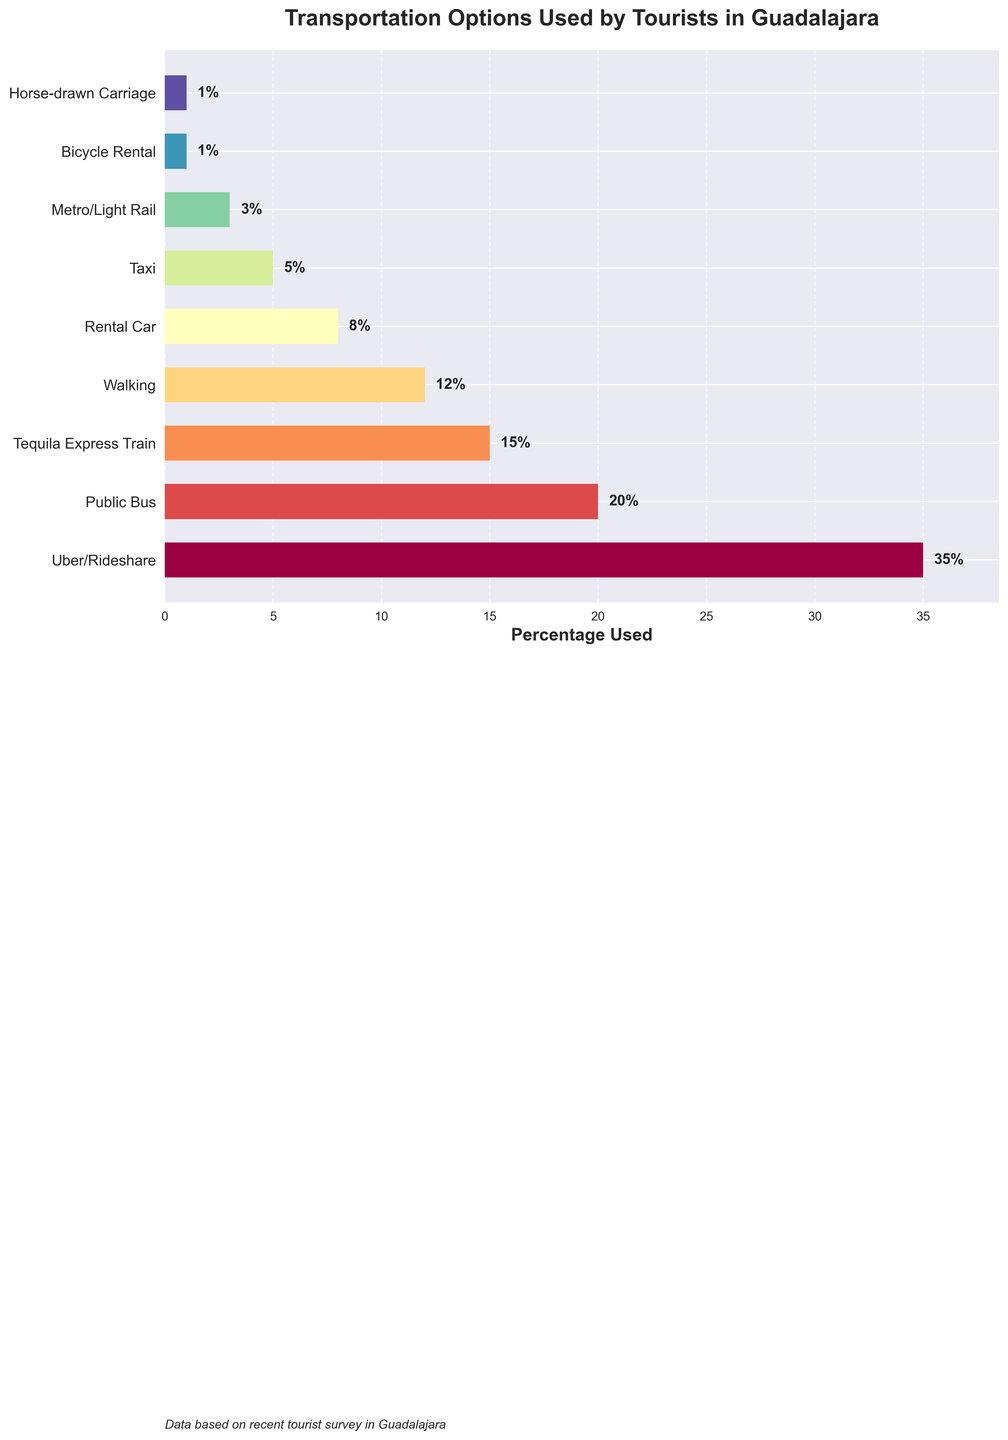What's the most used transportation option by tourists in Guadalajara? The bar chart shows the percentage usage of different transportation options. The longest bar represents the most used option, which is "Uber/Rideshare" with 35%.
Answer: Uber/Rideshare How much more popular is Uber/Rideshare compared to Walking? Uber/Rideshare is used by 35% of tourists and Walking by 12%. The difference is 35% - 12% = 23%.
Answer: 23% What is the total percentage of tourists that used either Public Bus or Tequila Express Train? The percentage for Public Bus is 20% and for Tequila Express Train is 15%. The total percentage is 20% + 15% = 35%.
Answer: 35% Which transportation option is the least used by tourists, and what is its percentage? The least used options have the shortest bars. Both "Bicycle Rental" and "Horse-drawn Carriage" are the least used, each with 1%.
Answer: Bicycle Rental and Horse-drawn Carriage (1%) Are there more tourists using Taxis or Rental Cars? The bar for Taxis is shorter than for Rental Cars. Taxis are used by 5% and Rental Cars by 8% of tourists. Therefore, more tourists use Rental Cars.
Answer: Rental Cars What is the combined percentage of tourists using Uber/Rideshare, Public Bus, and Tequila Express Train? The percentages for Uber/Rideshare, Public Bus, and Tequila Express Train are 35%, 20%, and 15% respectively. The combined percentage is 35% + 20% + 15% = 70%.
Answer: 70% Is the percentage of tourists using Metro/Light Rail lower than those using Taxis? Yes, the Metro/Light Rail is used by 3% of tourists while Taxis are used by 5%. 3% is indeed lower than 5%.
Answer: Yes What is the median usage percentage of all the transportation options listed? There are 9 transportation options. Arranging their percentages in ascending order: 1, 1, 3, 5, 8, 12, 15, 20, 35. The median value, the fifth element in the sorted list, is 8%.
Answer: 8% If you add the percentages of tourists using Walking, Rental Car, and Taxi, do they surpass the percentage of tourists using Uber/Rideshare? Walking (12%), Rental Car (8%), and Taxi (5%) add up to 12% + 8% + 5% = 25%. This does not surpass Uber/Rideshare's 35%.
Answer: No Which transportation options have usage percentages below 10%? The transportation options below 10% are Rental Car (8%), Taxi (5%), Metro/Light Rail (3%), Bicycle Rental (1%), and Horse-drawn Carriage (1%).
Answer: Rental Car, Taxi, Metro/Light Rail, Bicycle Rental, Horse-drawn Carriage 